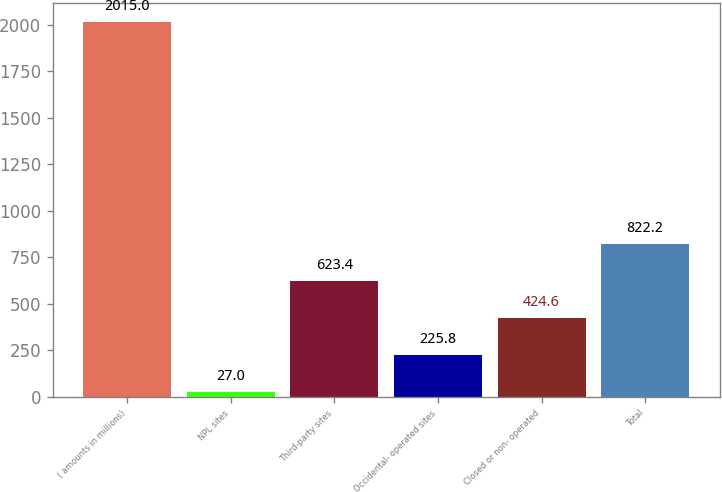<chart> <loc_0><loc_0><loc_500><loc_500><bar_chart><fcel>( amounts in millions)<fcel>NPL sites<fcel>Third-party sites<fcel>Occidental- operated sites<fcel>Closed or non- operated<fcel>Total<nl><fcel>2015<fcel>27<fcel>623.4<fcel>225.8<fcel>424.6<fcel>822.2<nl></chart> 